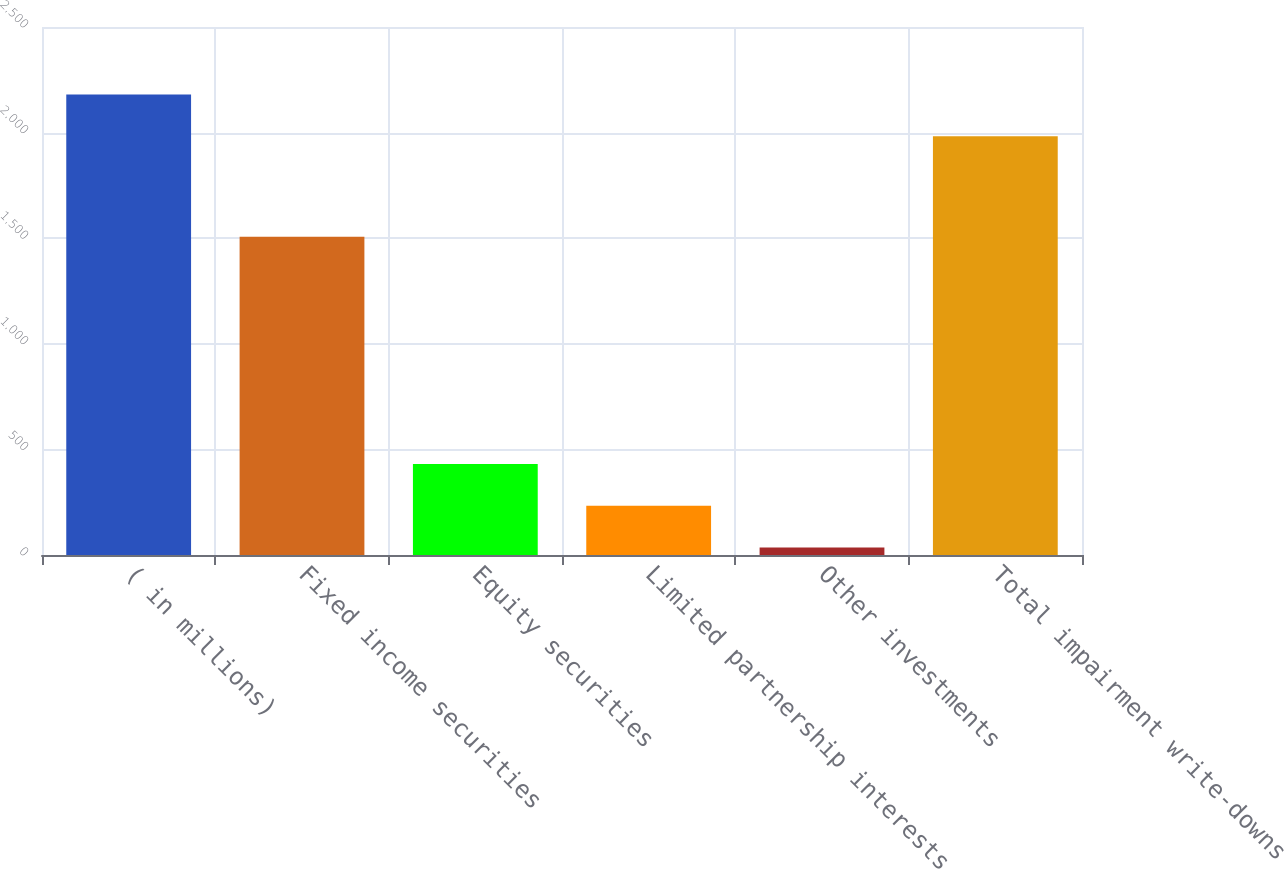Convert chart to OTSL. <chart><loc_0><loc_0><loc_500><loc_500><bar_chart><fcel>( in millions)<fcel>Fixed income securities<fcel>Equity securities<fcel>Limited partnership interests<fcel>Other investments<fcel>Total impairment write-downs<nl><fcel>2180.2<fcel>1507<fcel>430.4<fcel>233.2<fcel>36<fcel>1983<nl></chart> 